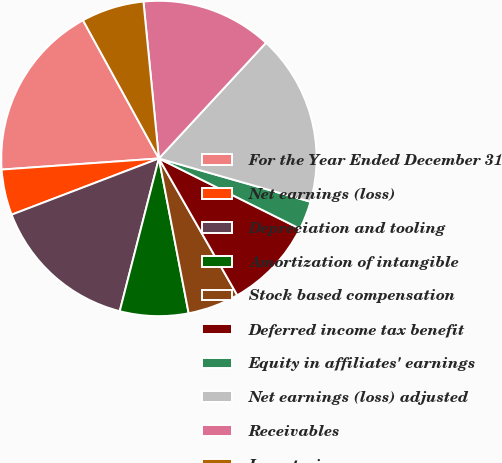Convert chart. <chart><loc_0><loc_0><loc_500><loc_500><pie_chart><fcel>For the Year Ended December 31<fcel>Net earnings (loss)<fcel>Depreciation and tooling<fcel>Amortization of intangible<fcel>Stock based compensation<fcel>Deferred income tax benefit<fcel>Equity in affiliates' earnings<fcel>Net earnings (loss) adjusted<fcel>Receivables<fcel>Inventories<nl><fcel>18.13%<fcel>4.68%<fcel>15.2%<fcel>7.02%<fcel>5.26%<fcel>9.36%<fcel>2.93%<fcel>17.54%<fcel>13.45%<fcel>6.43%<nl></chart> 